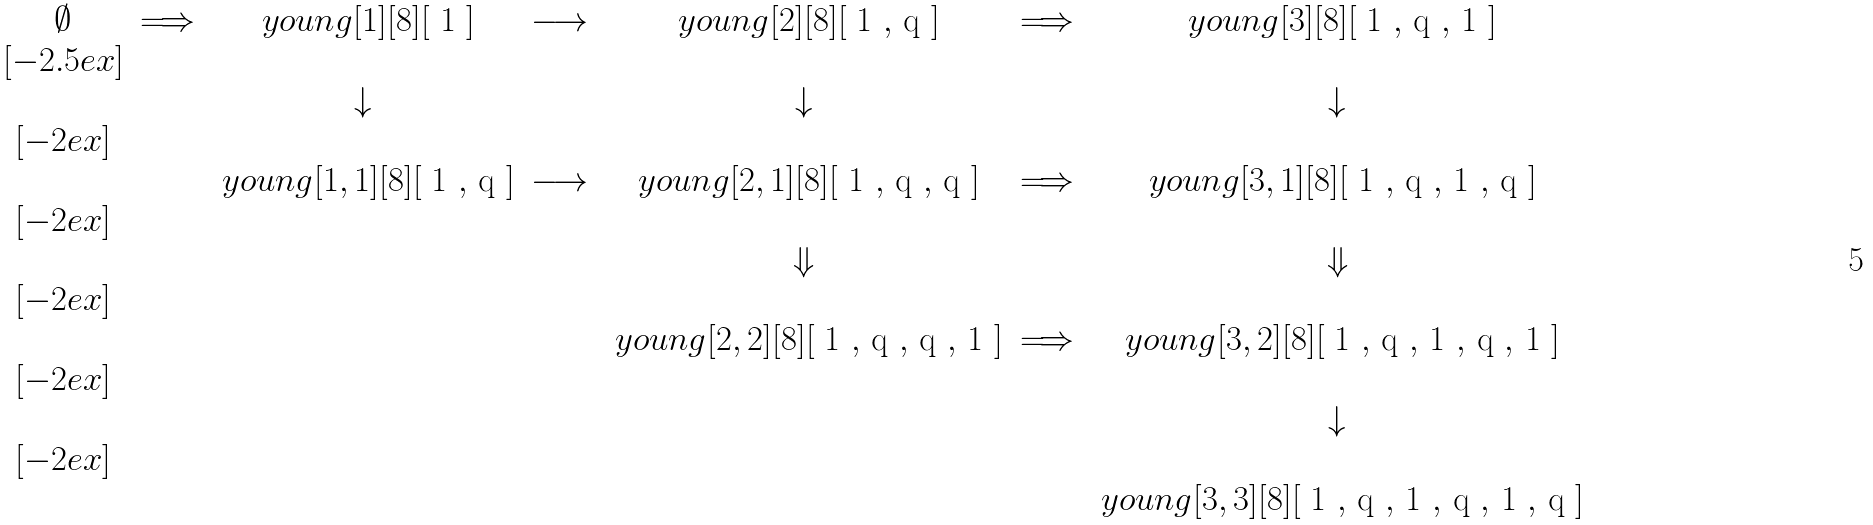<formula> <loc_0><loc_0><loc_500><loc_500>\begin{matrix} \emptyset & { \Longrightarrow } & \ y o u n g [ 1 ] [ 8 ] [ $ 1 $ ] & { \longrightarrow } & \ y o u n g [ 2 ] [ 8 ] [ $ 1 $ , $ q $ ] & { \Longrightarrow } & \ y o u n g [ 3 ] [ 8 ] [ $ 1 $ , $ q $ , $ 1 $ ] \\ [ - 2 . 5 e x ] \\ & & { \downarrow } & & { \downarrow } & & { \downarrow } \\ [ - 2 e x ] \\ & & \ y o u n g [ 1 , 1 ] [ 8 ] [ $ 1 $ , $ q $ ] & { \longrightarrow } & \ y o u n g [ 2 , 1 ] [ 8 ] [ $ 1 $ , $ q $ , $ q $ ] & { \Longrightarrow } & \ y o u n g [ 3 , 1 ] [ 8 ] [ $ 1 $ , $ q $ , $ 1 $ , $ q $ ] \\ [ - 2 e x ] \\ & & & & { \Downarrow } & & { \Downarrow } \\ [ - 2 e x ] \\ & & & & \ y o u n g [ 2 , 2 ] [ 8 ] [ $ 1 $ , $ q $ , $ q $ , $ 1 $ ] & { \Longrightarrow } & \ y o u n g [ 3 , 2 ] [ 8 ] [ $ 1 $ , $ q $ , $ 1 $ , $ q $ , $ 1 $ ] \\ [ - 2 e x ] \\ & & & & & & { \downarrow } \\ [ - 2 e x ] \\ & & & & & & \ y o u n g [ 3 , 3 ] [ 8 ] [ $ 1 $ , $ q $ , $ 1 $ , $ q $ , $ 1 $ , $ q $ ] \end{matrix}</formula> 